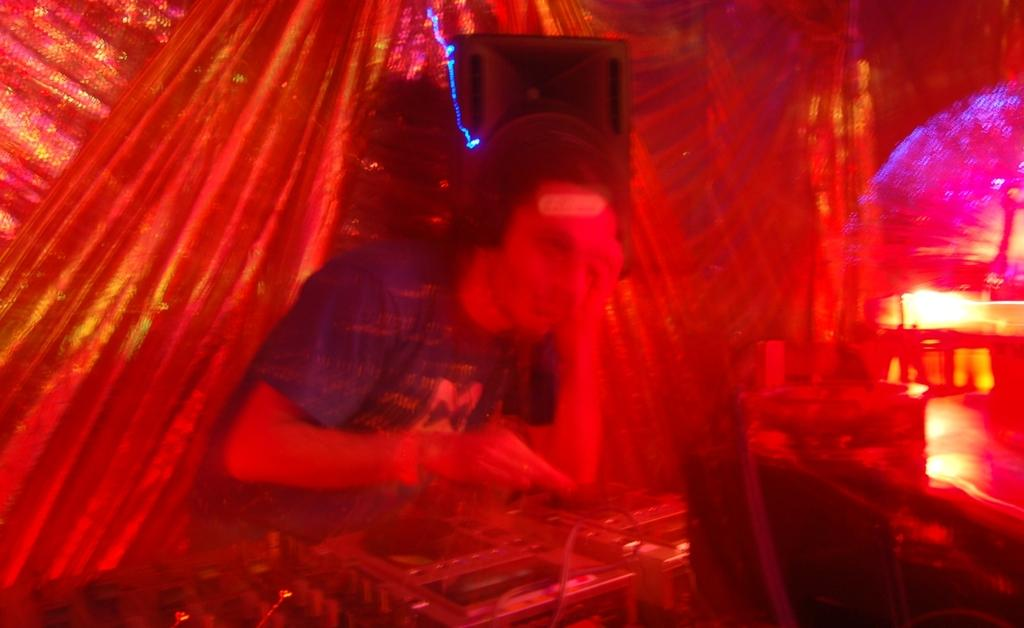Who is the main subject in the image? There is a man in the image. What is the man doing in the image? The man is playing a DJ. What can be seen in the background of the image? There are lights visible in the image. What is used for amplifying sound in the image? There is a speaker in the image. Where is the nest located in the image? There is no nest present in the image. What type of doll can be seen in the image? There is no doll present in the image. 